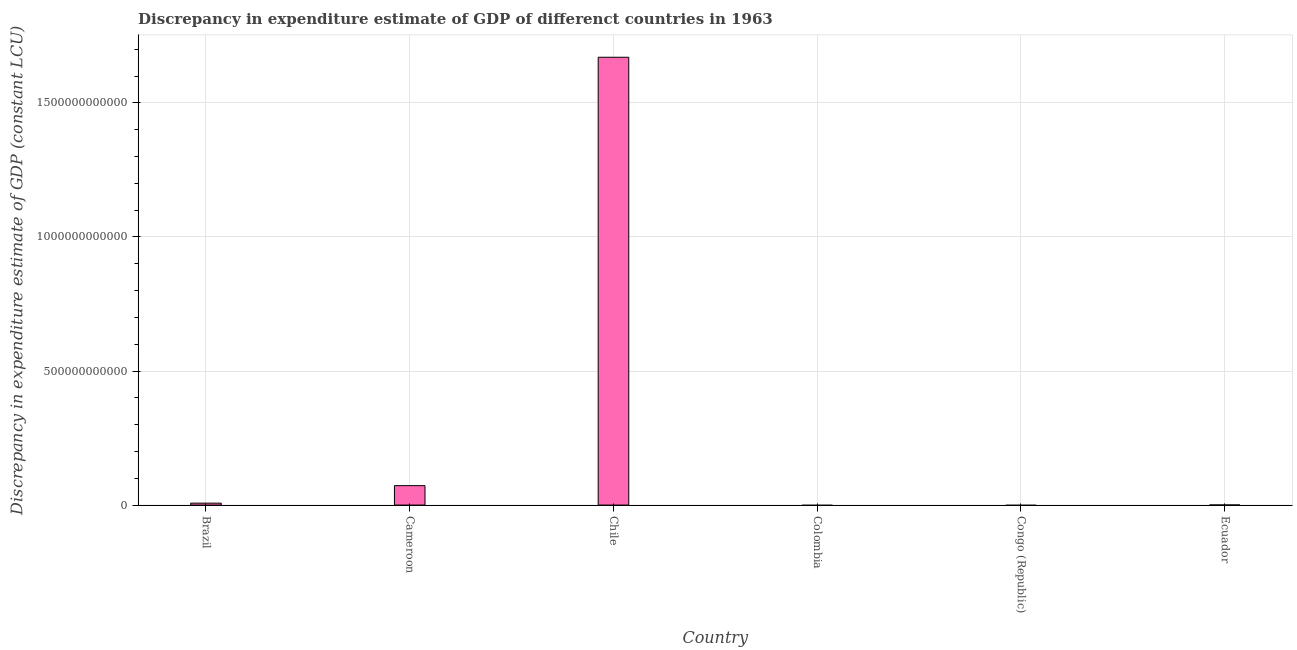Does the graph contain any zero values?
Your answer should be very brief. Yes. What is the title of the graph?
Give a very brief answer. Discrepancy in expenditure estimate of GDP of differenct countries in 1963. What is the label or title of the Y-axis?
Make the answer very short. Discrepancy in expenditure estimate of GDP (constant LCU). What is the discrepancy in expenditure estimate of gdp in Cameroon?
Offer a very short reply. 7.25e+1. Across all countries, what is the maximum discrepancy in expenditure estimate of gdp?
Offer a terse response. 1.67e+12. Across all countries, what is the minimum discrepancy in expenditure estimate of gdp?
Your answer should be very brief. 0. What is the sum of the discrepancy in expenditure estimate of gdp?
Offer a terse response. 1.75e+12. What is the difference between the discrepancy in expenditure estimate of gdp in Brazil and Ecuador?
Provide a succinct answer. 6.88e+09. What is the average discrepancy in expenditure estimate of gdp per country?
Offer a very short reply. 2.92e+11. What is the median discrepancy in expenditure estimate of gdp?
Keep it short and to the point. 3.73e+09. What is the ratio of the discrepancy in expenditure estimate of gdp in Brazil to that in Cameroon?
Give a very brief answer. 0.1. Is the difference between the discrepancy in expenditure estimate of gdp in Cameroon and Chile greater than the difference between any two countries?
Your answer should be compact. No. What is the difference between the highest and the second highest discrepancy in expenditure estimate of gdp?
Ensure brevity in your answer.  1.60e+12. What is the difference between the highest and the lowest discrepancy in expenditure estimate of gdp?
Offer a very short reply. 1.67e+12. Are all the bars in the graph horizontal?
Provide a succinct answer. No. What is the difference between two consecutive major ticks on the Y-axis?
Provide a succinct answer. 5.00e+11. What is the Discrepancy in expenditure estimate of GDP (constant LCU) in Brazil?
Your answer should be compact. 7.17e+09. What is the Discrepancy in expenditure estimate of GDP (constant LCU) of Cameroon?
Your answer should be very brief. 7.25e+1. What is the Discrepancy in expenditure estimate of GDP (constant LCU) in Chile?
Make the answer very short. 1.67e+12. What is the Discrepancy in expenditure estimate of GDP (constant LCU) of Colombia?
Your response must be concise. 0. What is the Discrepancy in expenditure estimate of GDP (constant LCU) of Ecuador?
Your answer should be very brief. 2.85e+08. What is the difference between the Discrepancy in expenditure estimate of GDP (constant LCU) in Brazil and Cameroon?
Offer a very short reply. -6.53e+1. What is the difference between the Discrepancy in expenditure estimate of GDP (constant LCU) in Brazil and Chile?
Your answer should be compact. -1.66e+12. What is the difference between the Discrepancy in expenditure estimate of GDP (constant LCU) in Brazil and Ecuador?
Keep it short and to the point. 6.88e+09. What is the difference between the Discrepancy in expenditure estimate of GDP (constant LCU) in Cameroon and Chile?
Your answer should be compact. -1.60e+12. What is the difference between the Discrepancy in expenditure estimate of GDP (constant LCU) in Cameroon and Ecuador?
Your answer should be very brief. 7.22e+1. What is the difference between the Discrepancy in expenditure estimate of GDP (constant LCU) in Chile and Ecuador?
Your answer should be very brief. 1.67e+12. What is the ratio of the Discrepancy in expenditure estimate of GDP (constant LCU) in Brazil to that in Cameroon?
Give a very brief answer. 0.1. What is the ratio of the Discrepancy in expenditure estimate of GDP (constant LCU) in Brazil to that in Chile?
Make the answer very short. 0. What is the ratio of the Discrepancy in expenditure estimate of GDP (constant LCU) in Brazil to that in Ecuador?
Ensure brevity in your answer.  25.13. What is the ratio of the Discrepancy in expenditure estimate of GDP (constant LCU) in Cameroon to that in Chile?
Give a very brief answer. 0.04. What is the ratio of the Discrepancy in expenditure estimate of GDP (constant LCU) in Cameroon to that in Ecuador?
Your answer should be compact. 254. What is the ratio of the Discrepancy in expenditure estimate of GDP (constant LCU) in Chile to that in Ecuador?
Offer a very short reply. 5855.08. 